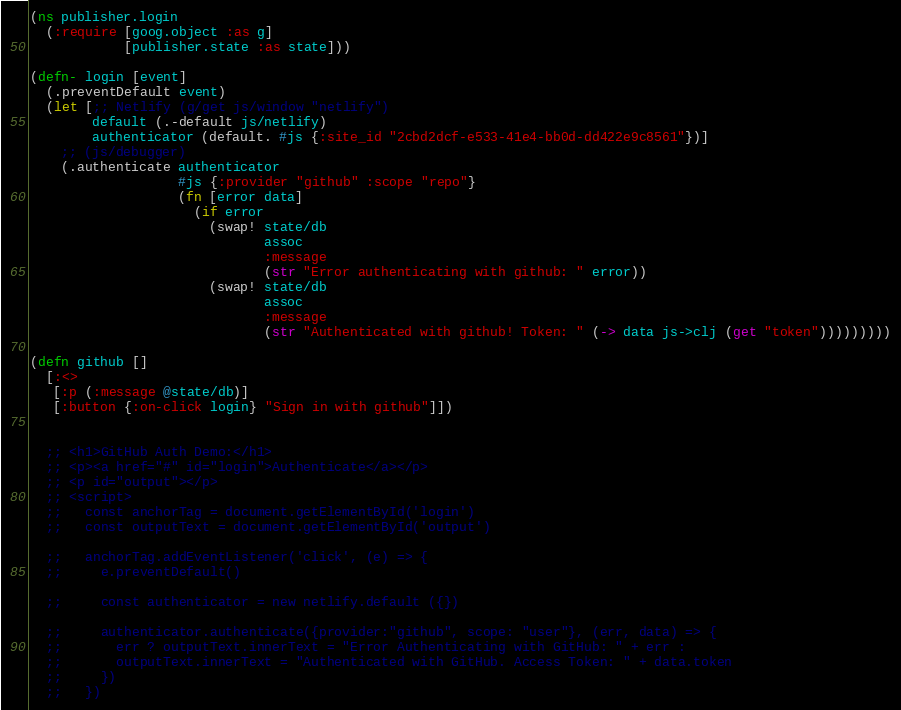Convert code to text. <code><loc_0><loc_0><loc_500><loc_500><_Clojure_>(ns publisher.login
  (:require [goog.object :as g]
            [publisher.state :as state]))

(defn- login [event]
  (.preventDefault event)
  (let [;; Netlify (g/get js/window "netlify")
        default (.-default js/netlify)
        authenticator (default. #js {:site_id "2cbd2dcf-e533-41e4-bb0d-dd422e9c8561"})]
    ;; (js/debugger)
    (.authenticate authenticator
                   #js {:provider "github" :scope "repo"}
                   (fn [error data]
                     (if error
                       (swap! state/db
                              assoc
                              :message
                              (str "Error authenticating with github: " error))
                       (swap! state/db
                              assoc
                              :message
                              (str "Authenticated with github! Token: " (-> data js->clj (get "token")))))))))

(defn github []
  [:<>
   [:p (:message @state/db)]
   [:button {:on-click login} "Sign in with github"]])


  ;; <h1>GitHub Auth Demo:</h1>
  ;; <p><a href="#" id="login">Authenticate</a></p>
  ;; <p id="output"></p>
  ;; <script>
  ;;   const anchorTag = document.getElementById('login')
  ;;   const outputText = document.getElementById('output')

  ;;   anchorTag.addEventListener('click', (e) => {
  ;;     e.preventDefault()

  ;;     const authenticator = new netlify.default ({})

  ;;     authenticator.authenticate({provider:"github", scope: "user"}, (err, data) => {
  ;;       err ? outputText.innerText = "Error Authenticating with GitHub: " + err :
  ;;       outputText.innerText = "Authenticated with GitHub. Access Token: " + data.token
  ;;     })
  ;;   })
</code> 